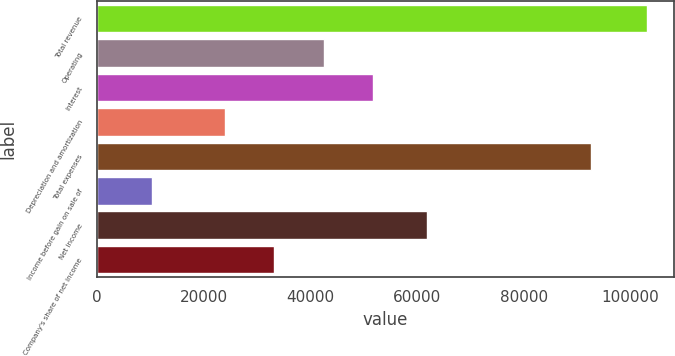<chart> <loc_0><loc_0><loc_500><loc_500><bar_chart><fcel>Total revenue<fcel>Operating<fcel>Interest<fcel>Depreciation and amortization<fcel>Total expenses<fcel>Income before gain on sale of<fcel>Net income<fcel>Company's share of net income<nl><fcel>103050<fcel>42490.6<fcel>51756.4<fcel>23959<fcel>92658<fcel>10392<fcel>61776<fcel>33224.8<nl></chart> 